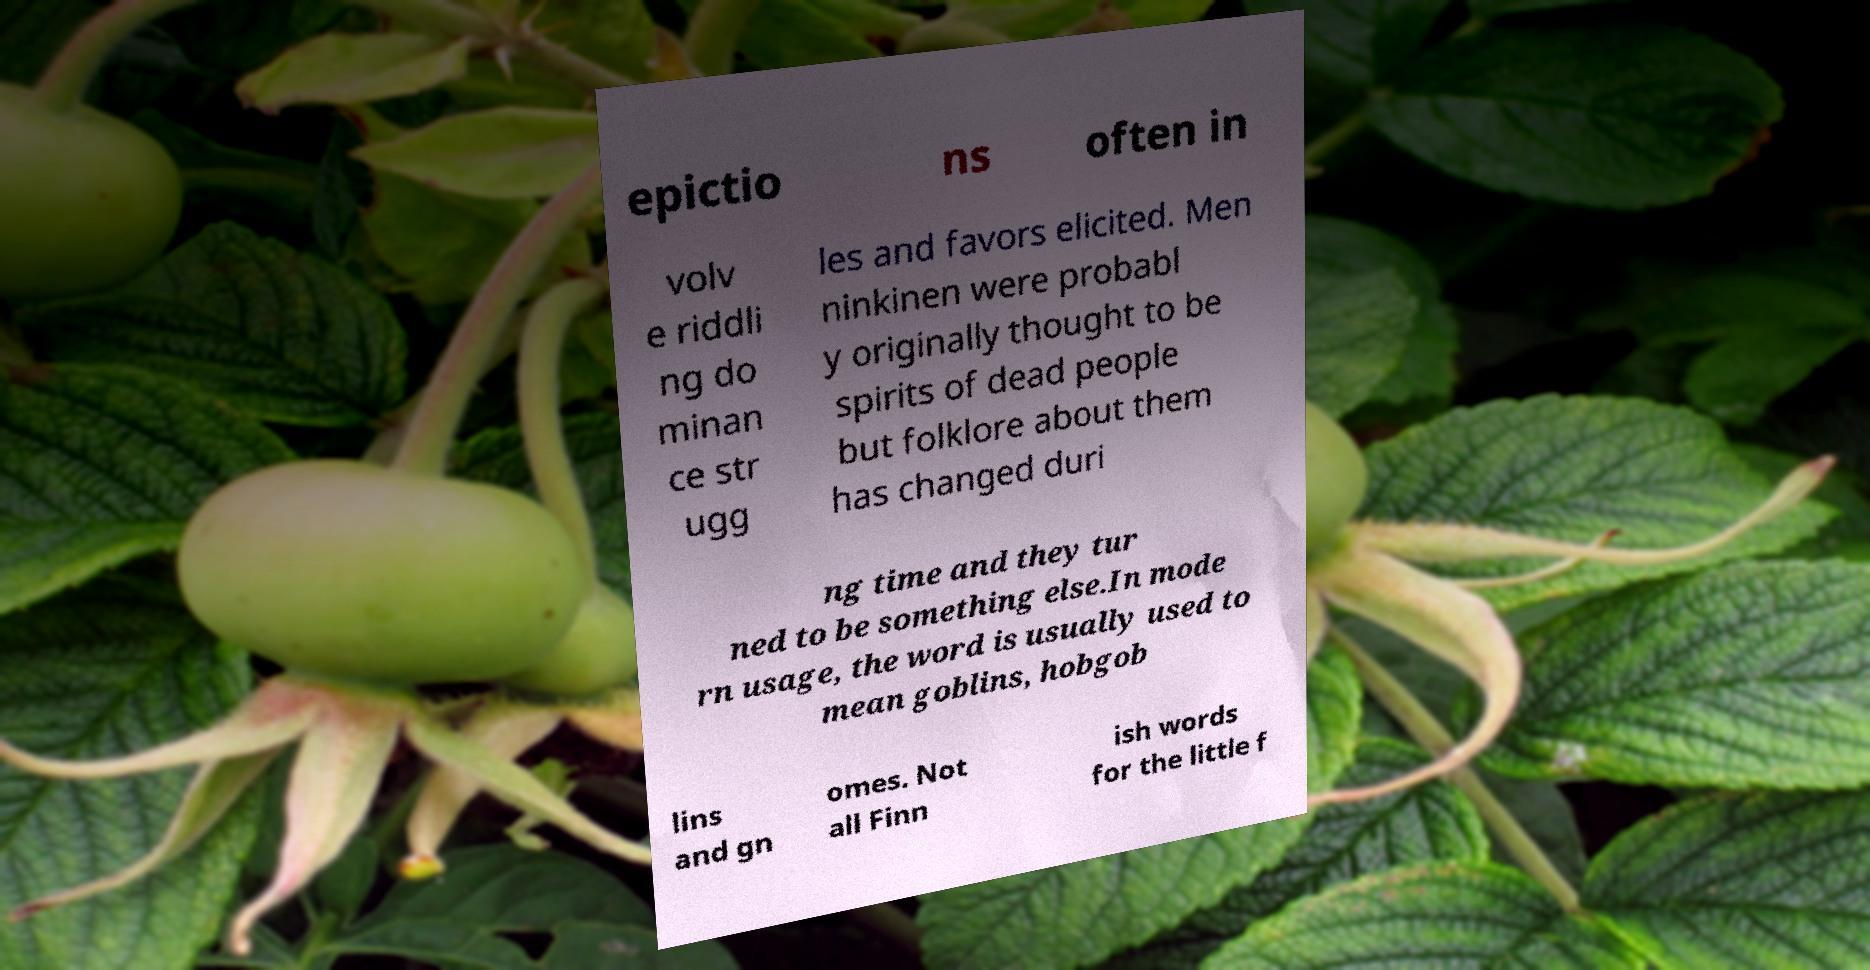Could you assist in decoding the text presented in this image and type it out clearly? epictio ns often in volv e riddli ng do minan ce str ugg les and favors elicited. Men ninkinen were probabl y originally thought to be spirits of dead people but folklore about them has changed duri ng time and they tur ned to be something else.In mode rn usage, the word is usually used to mean goblins, hobgob lins and gn omes. Not all Finn ish words for the little f 